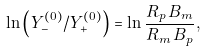Convert formula to latex. <formula><loc_0><loc_0><loc_500><loc_500>\ln \left ( Y _ { - } ^ { ( 0 ) } / Y _ { + } ^ { ( 0 ) } \right ) = \ln \frac { R _ { p } \, B _ { m } } { R _ { m } \, B _ { p } } ,</formula> 